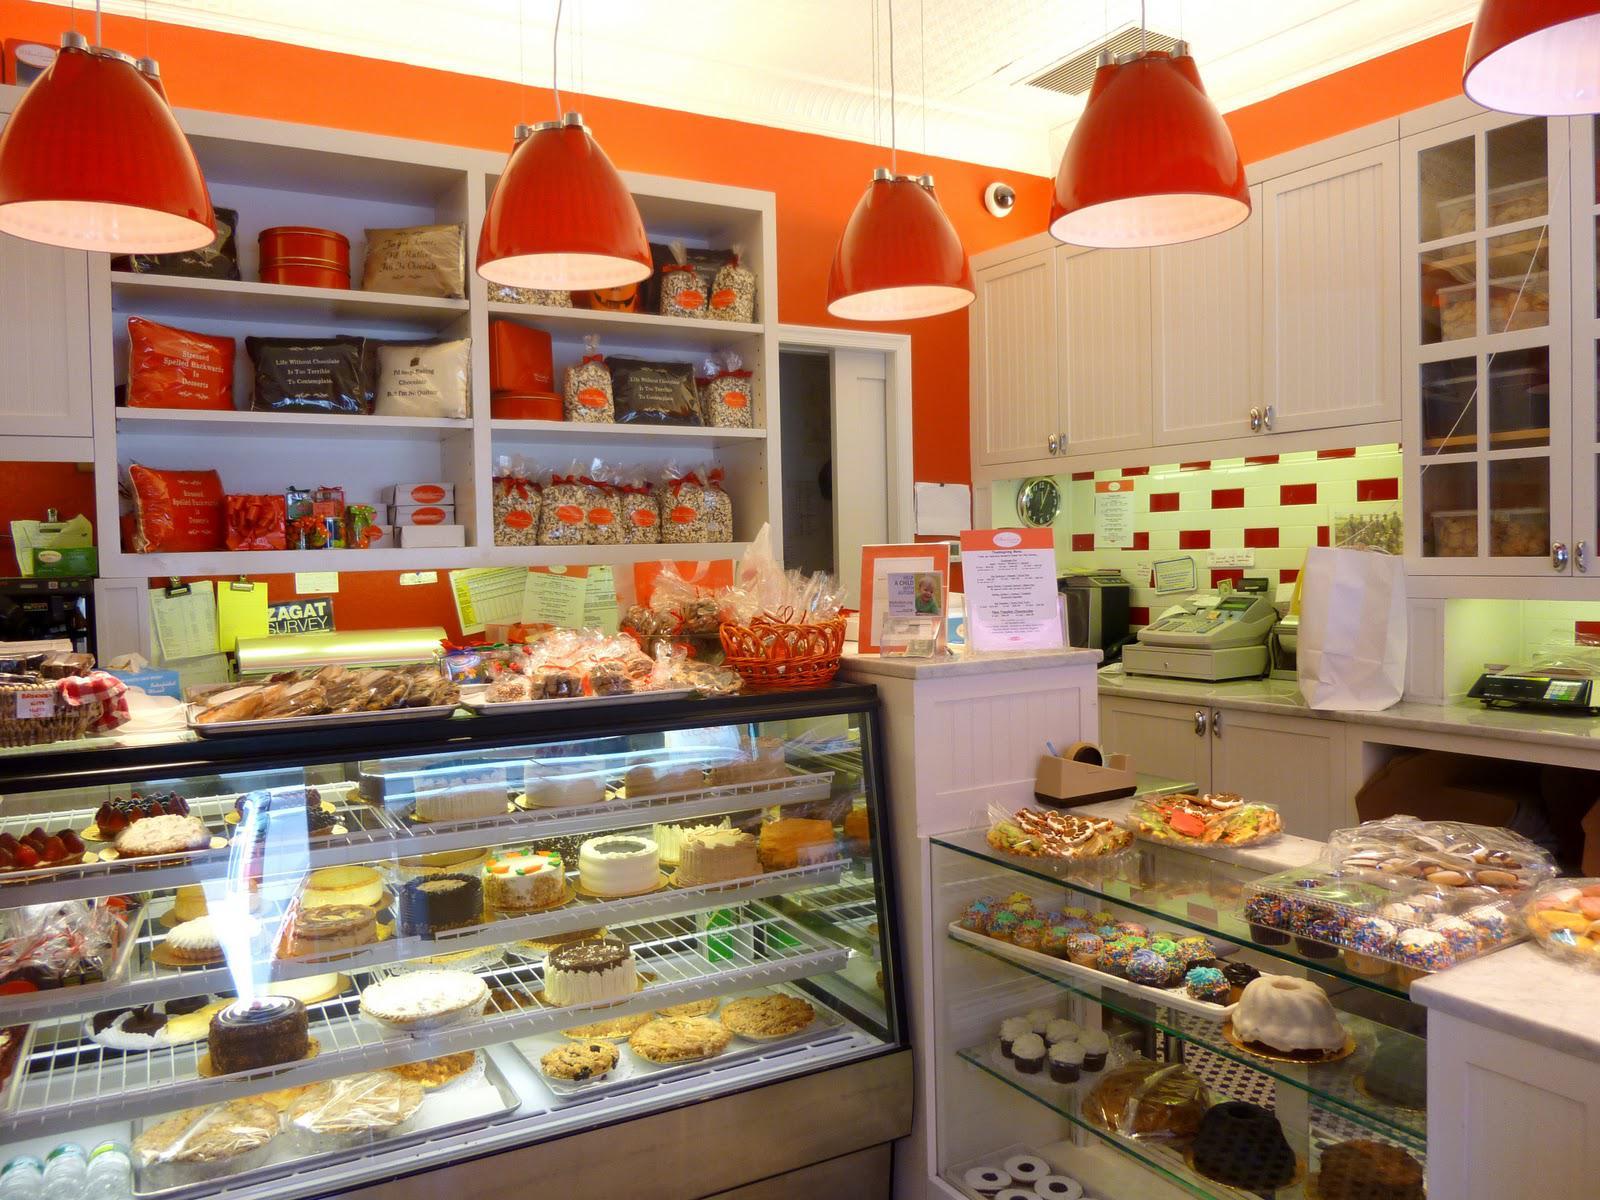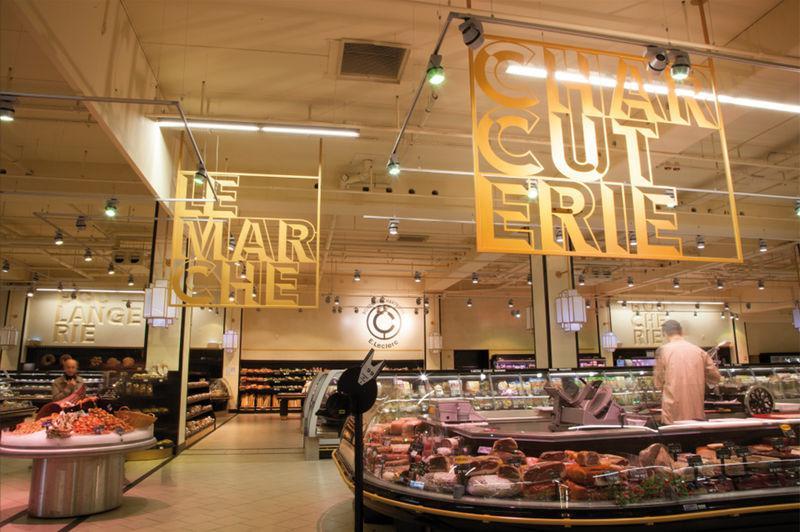The first image is the image on the left, the second image is the image on the right. Evaluate the accuracy of this statement regarding the images: "There are red lamps hanging from the ceiling.". Is it true? Answer yes or no. Yes. The first image is the image on the left, the second image is the image on the right. Analyze the images presented: Is the assertion "One bakery has a glassed display that curves around a corner." valid? Answer yes or no. Yes. The first image is the image on the left, the second image is the image on the right. Assess this claim about the two images: "One display cabinet is a soft green color.". Correct or not? Answer yes or no. No. 